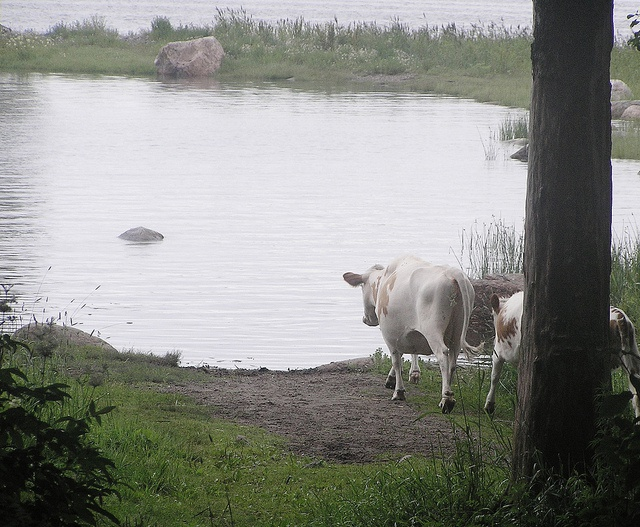Describe the objects in this image and their specific colors. I can see cow in darkgray, gray, lightgray, and black tones and cow in darkgray, black, gray, and lightgray tones in this image. 